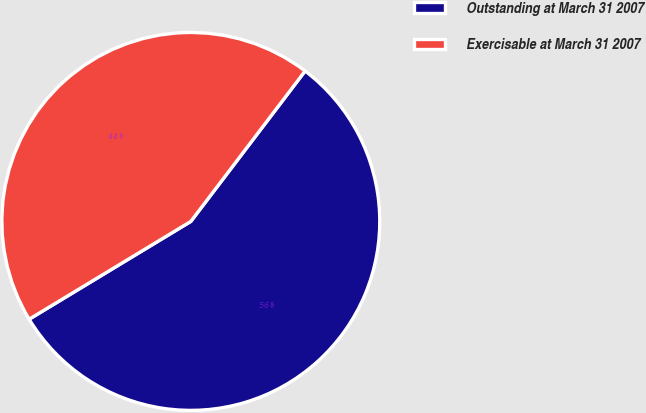Convert chart to OTSL. <chart><loc_0><loc_0><loc_500><loc_500><pie_chart><fcel>Outstanding at March 31 2007<fcel>Exercisable at March 31 2007<nl><fcel>56.0%<fcel>44.0%<nl></chart> 